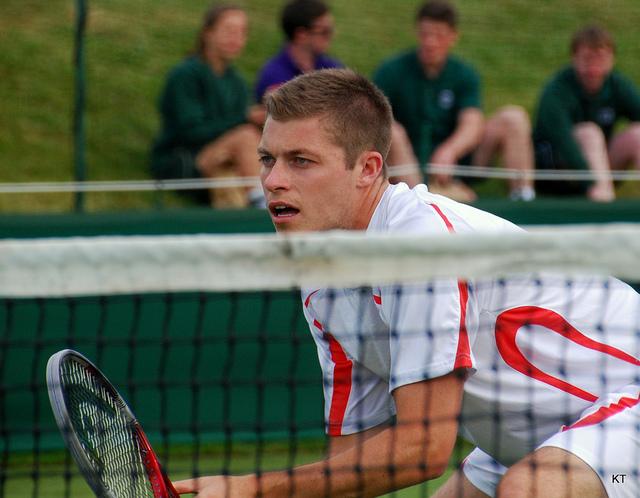What position is the man in?
Quick response, please. Crouching. Is this man playing volleyball?
Write a very short answer. No. Are there many spectators?
Write a very short answer. No. 